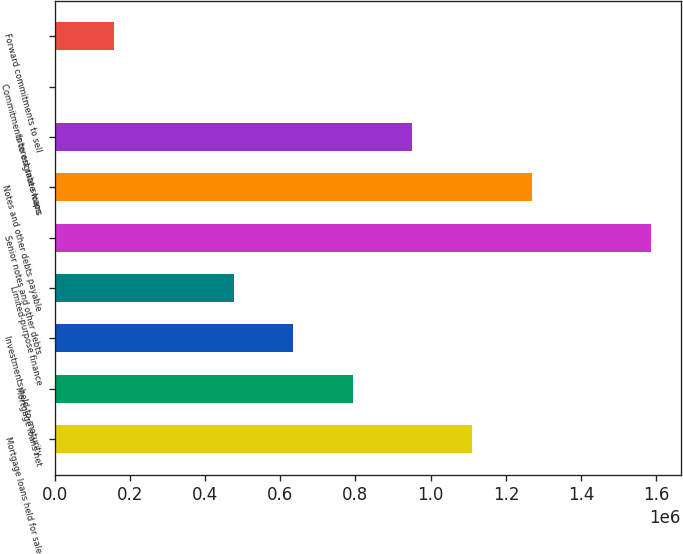Convert chart to OTSL. <chart><loc_0><loc_0><loc_500><loc_500><bar_chart><fcel>Mortgage loans held for sale<fcel>Mortgage loans net<fcel>Investments held-to-maturity<fcel>Limited-purpose finance<fcel>Senior notes and other debts<fcel>Notes and other debts payable<fcel>Interest rate swaps<fcel>Commitments to originate loans<fcel>Forward commitments to sell<nl><fcel>1.10993e+06<fcel>793013<fcel>634554<fcel>476095<fcel>1.58531e+06<fcel>1.26839e+06<fcel>951472<fcel>717<fcel>159176<nl></chart> 